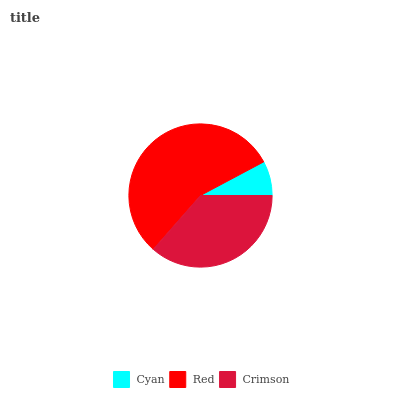Is Cyan the minimum?
Answer yes or no. Yes. Is Red the maximum?
Answer yes or no. Yes. Is Crimson the minimum?
Answer yes or no. No. Is Crimson the maximum?
Answer yes or no. No. Is Red greater than Crimson?
Answer yes or no. Yes. Is Crimson less than Red?
Answer yes or no. Yes. Is Crimson greater than Red?
Answer yes or no. No. Is Red less than Crimson?
Answer yes or no. No. Is Crimson the high median?
Answer yes or no. Yes. Is Crimson the low median?
Answer yes or no. Yes. Is Cyan the high median?
Answer yes or no. No. Is Red the low median?
Answer yes or no. No. 